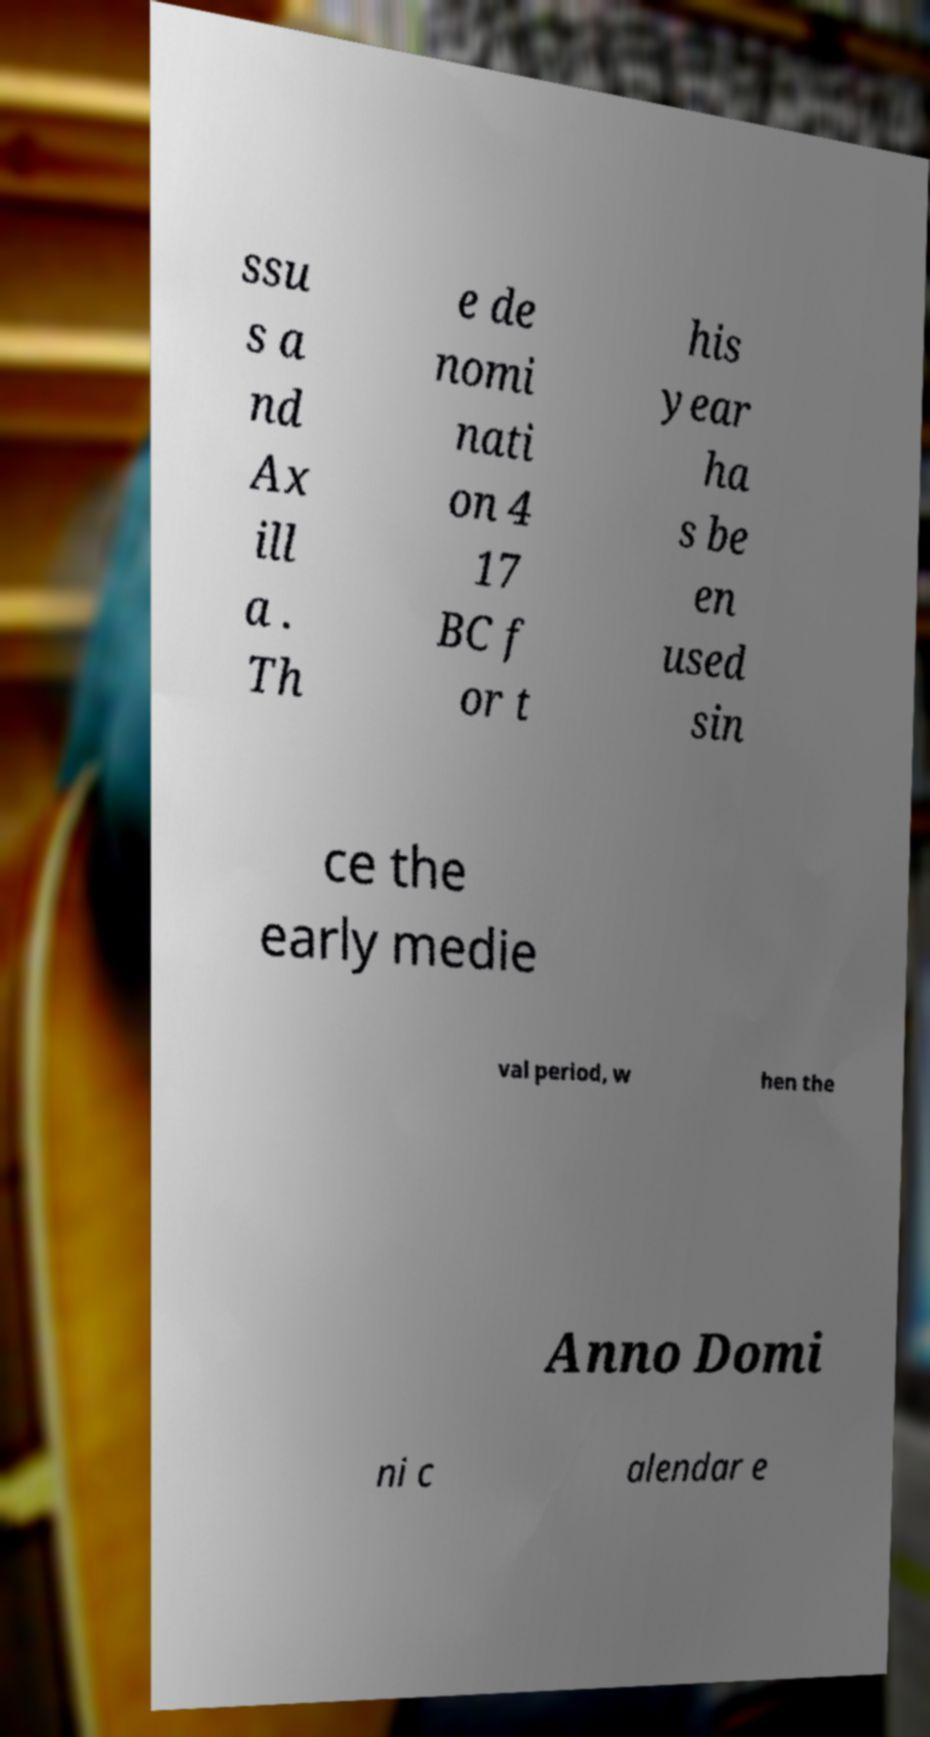Please identify and transcribe the text found in this image. ssu s a nd Ax ill a . Th e de nomi nati on 4 17 BC f or t his year ha s be en used sin ce the early medie val period, w hen the Anno Domi ni c alendar e 